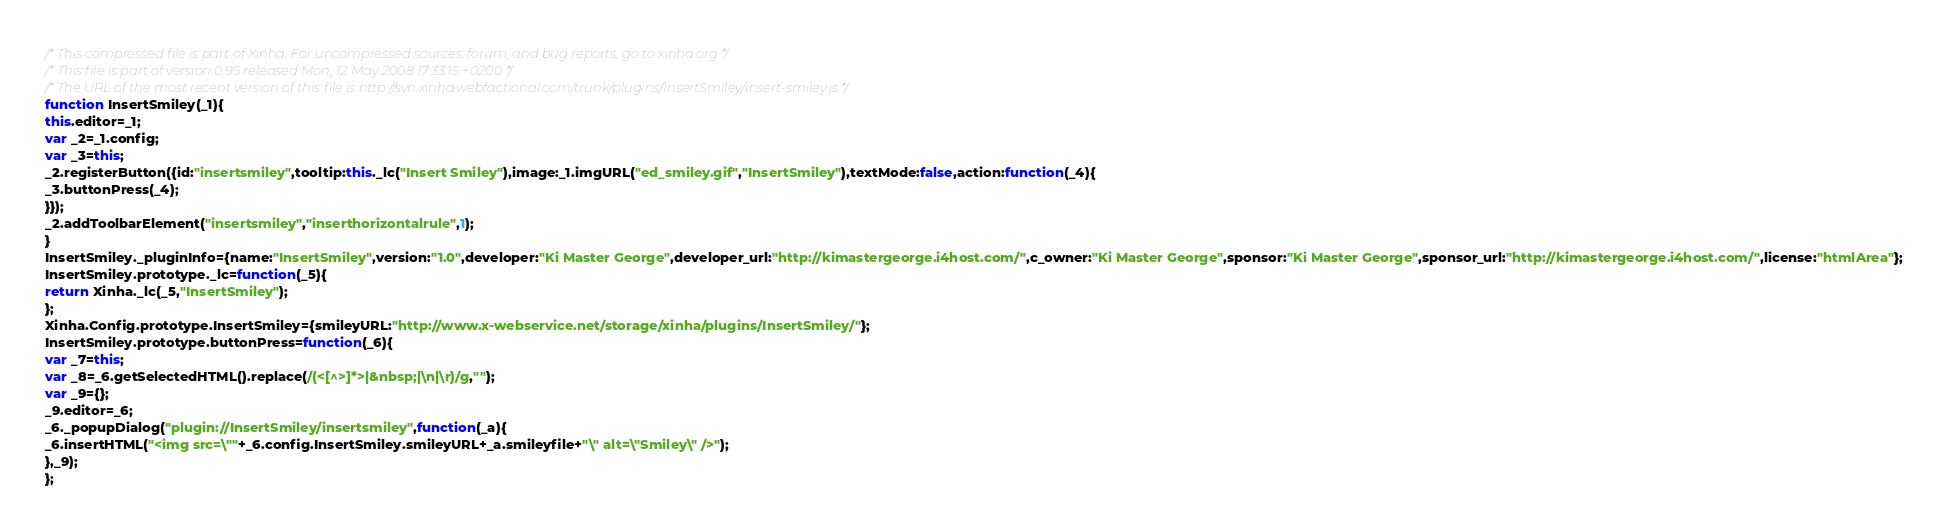Convert code to text. <code><loc_0><loc_0><loc_500><loc_500><_JavaScript_>/* This compressed file is part of Xinha. For uncompressed sources, forum, and bug reports, go to xinha.org */
/* This file is part of version 0.95 released Mon, 12 May 2008 17:33:15 +0200 */
/* The URL of the most recent version of this file is http://svn.xinha.webfactional.com/trunk/plugins/InsertSmiley/insert-smiley.js */
function InsertSmiley(_1){
this.editor=_1;
var _2=_1.config;
var _3=this;
_2.registerButton({id:"insertsmiley",tooltip:this._lc("Insert Smiley"),image:_1.imgURL("ed_smiley.gif","InsertSmiley"),textMode:false,action:function(_4){
_3.buttonPress(_4);
}});
_2.addToolbarElement("insertsmiley","inserthorizontalrule",1);
}
InsertSmiley._pluginInfo={name:"InsertSmiley",version:"1.0",developer:"Ki Master George",developer_url:"http://kimastergeorge.i4host.com/",c_owner:"Ki Master George",sponsor:"Ki Master George",sponsor_url:"http://kimastergeorge.i4host.com/",license:"htmlArea"};
InsertSmiley.prototype._lc=function(_5){
return Xinha._lc(_5,"InsertSmiley");
};
Xinha.Config.prototype.InsertSmiley={smileyURL:"http://www.x-webservice.net/storage/xinha/plugins/InsertSmiley/"};
InsertSmiley.prototype.buttonPress=function(_6){
var _7=this;
var _8=_6.getSelectedHTML().replace(/(<[^>]*>|&nbsp;|\n|\r)/g,"");
var _9={};
_9.editor=_6;
_6._popupDialog("plugin://InsertSmiley/insertsmiley",function(_a){
_6.insertHTML("<img src=\""+_6.config.InsertSmiley.smileyURL+_a.smileyfile+"\" alt=\"Smiley\" />");
},_9);
};

</code> 